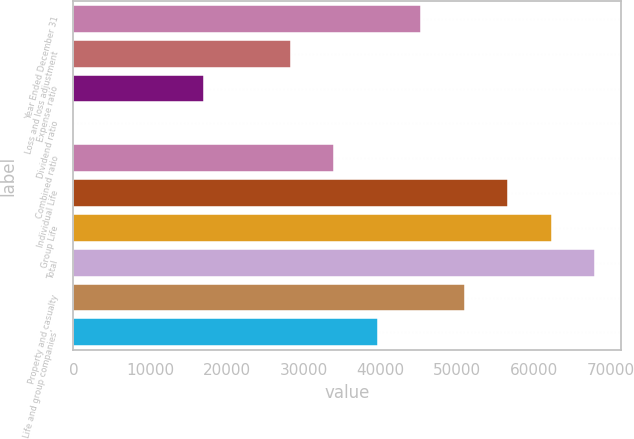Convert chart to OTSL. <chart><loc_0><loc_0><loc_500><loc_500><bar_chart><fcel>Year Ended December 31<fcel>Loss and loss adjustment<fcel>Expense ratio<fcel>Dividend ratio<fcel>Combined ratio<fcel>Individual Life<fcel>Group Life<fcel>Total<fcel>Property and casualty<fcel>Life and group companies'<nl><fcel>45316<fcel>28322.6<fcel>16993.6<fcel>0.2<fcel>33987.1<fcel>56645<fcel>62309.5<fcel>67974<fcel>50980.5<fcel>39651.6<nl></chart> 